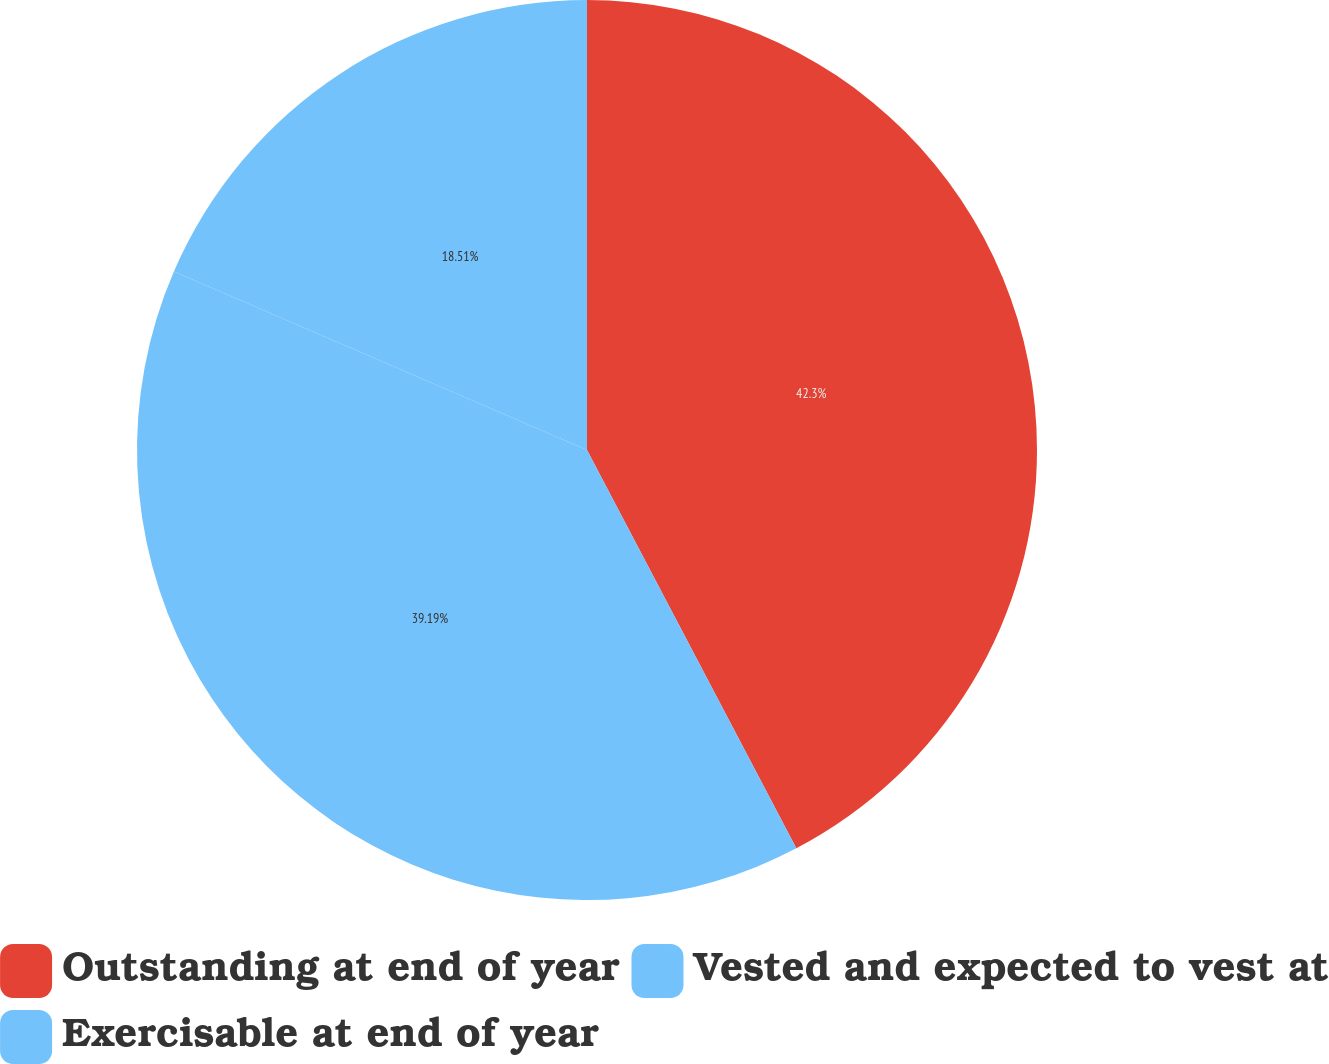Convert chart to OTSL. <chart><loc_0><loc_0><loc_500><loc_500><pie_chart><fcel>Outstanding at end of year<fcel>Vested and expected to vest at<fcel>Exercisable at end of year<nl><fcel>42.3%<fcel>39.19%<fcel>18.51%<nl></chart> 